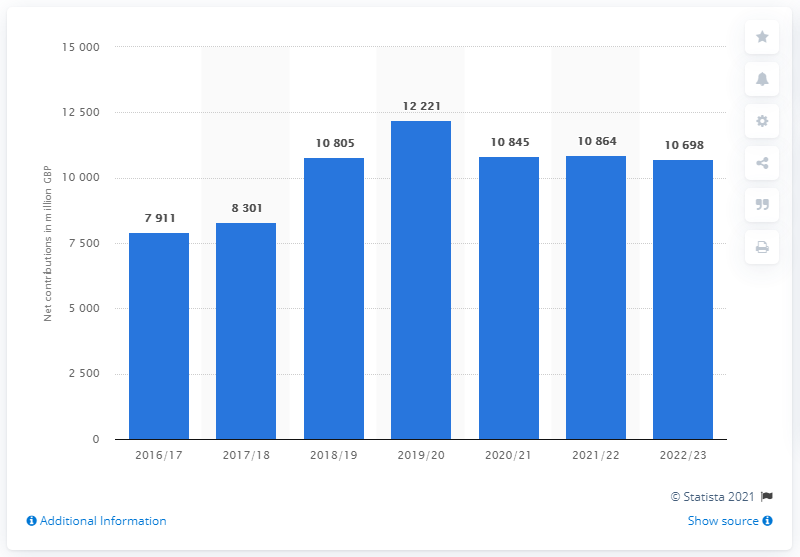Identify some key points in this picture. The estimated amount of contributions to the European Union budget for 2019/20 is 122,210.. 